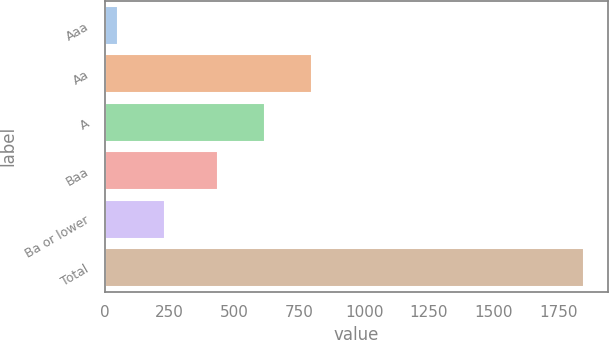Convert chart to OTSL. <chart><loc_0><loc_0><loc_500><loc_500><bar_chart><fcel>Aaa<fcel>Aa<fcel>A<fcel>Baa<fcel>Ba or lower<fcel>Total<nl><fcel>52<fcel>797.4<fcel>617.7<fcel>438<fcel>231.7<fcel>1849<nl></chart> 